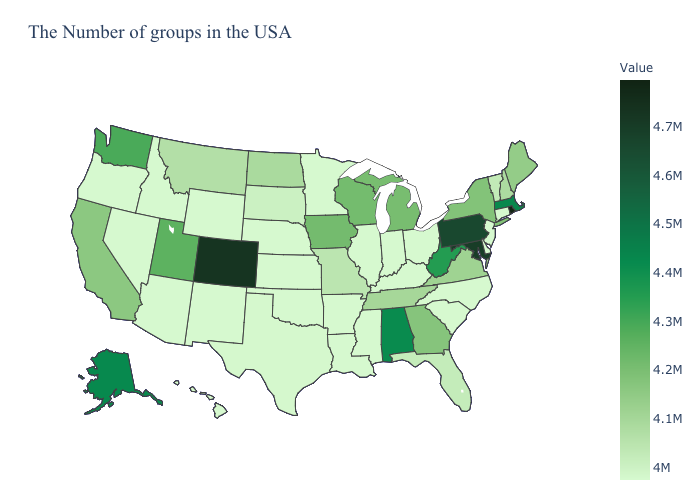Does the map have missing data?
Give a very brief answer. No. Which states have the highest value in the USA?
Be succinct. Rhode Island. Which states hav the highest value in the MidWest?
Short answer required. Iowa. 